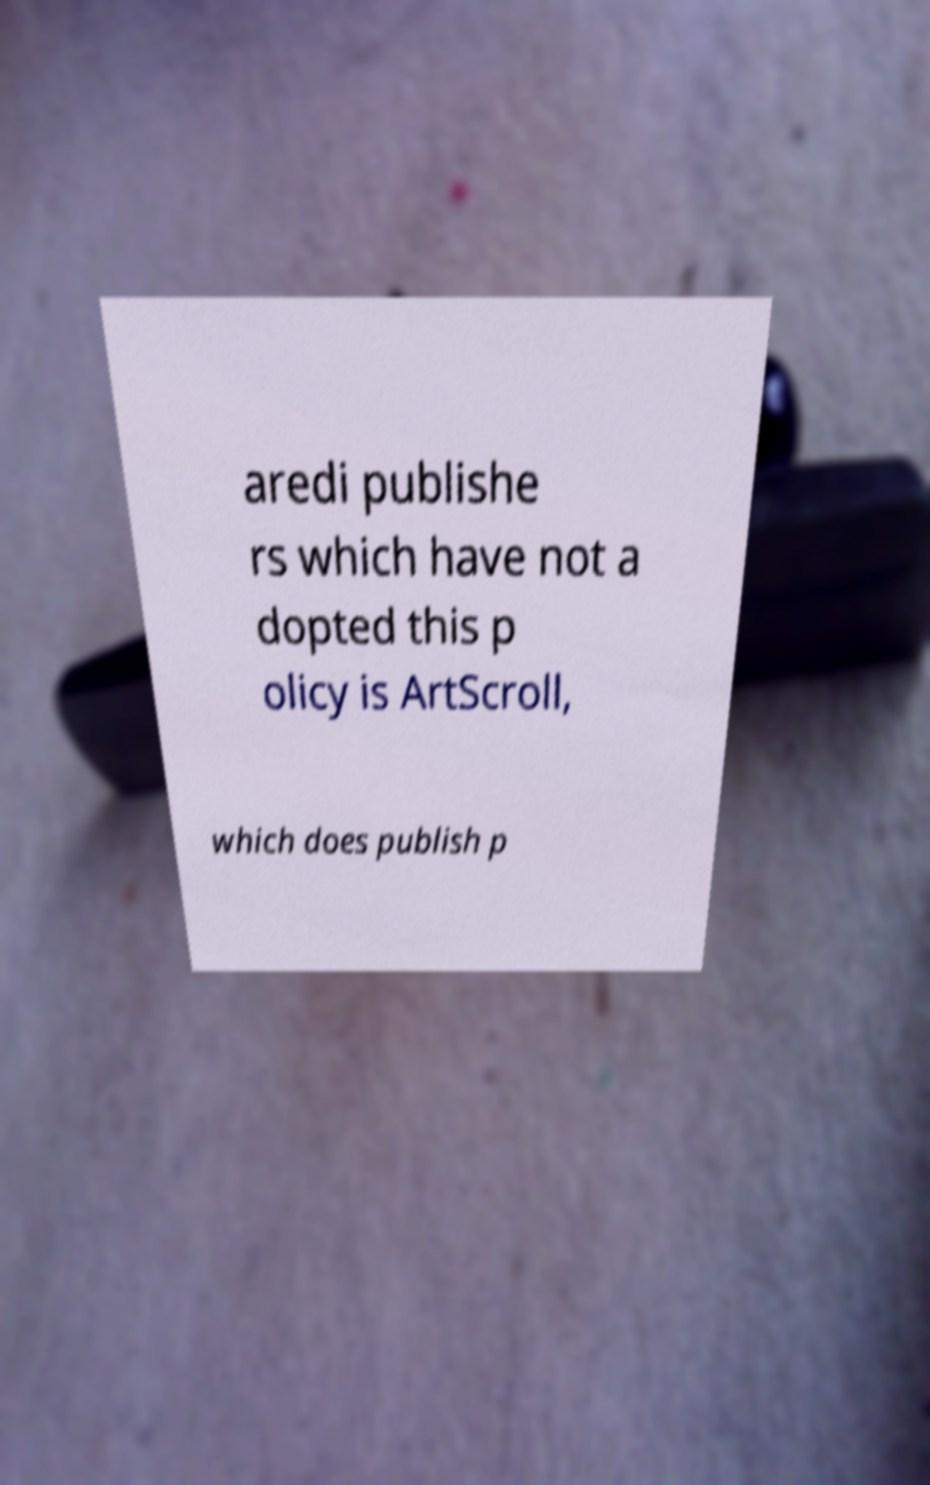Could you assist in decoding the text presented in this image and type it out clearly? aredi publishe rs which have not a dopted this p olicy is ArtScroll, which does publish p 